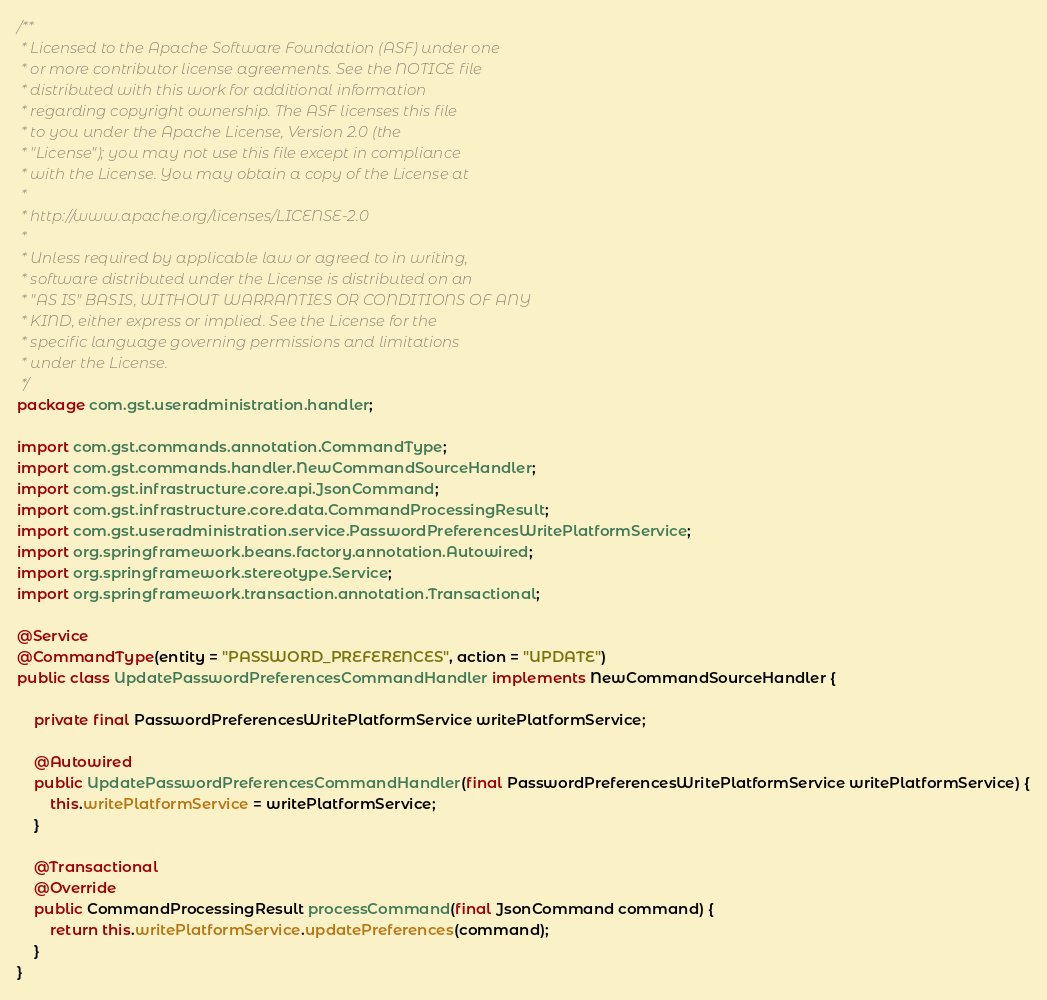<code> <loc_0><loc_0><loc_500><loc_500><_Java_>/**
 * Licensed to the Apache Software Foundation (ASF) under one
 * or more contributor license agreements. See the NOTICE file
 * distributed with this work for additional information
 * regarding copyright ownership. The ASF licenses this file
 * to you under the Apache License, Version 2.0 (the
 * "License"); you may not use this file except in compliance
 * with the License. You may obtain a copy of the License at
 *
 * http://www.apache.org/licenses/LICENSE-2.0
 *
 * Unless required by applicable law or agreed to in writing,
 * software distributed under the License is distributed on an
 * "AS IS" BASIS, WITHOUT WARRANTIES OR CONDITIONS OF ANY
 * KIND, either express or implied. See the License for the
 * specific language governing permissions and limitations
 * under the License.
 */
package com.gst.useradministration.handler;

import com.gst.commands.annotation.CommandType;
import com.gst.commands.handler.NewCommandSourceHandler;
import com.gst.infrastructure.core.api.JsonCommand;
import com.gst.infrastructure.core.data.CommandProcessingResult;
import com.gst.useradministration.service.PasswordPreferencesWritePlatformService;
import org.springframework.beans.factory.annotation.Autowired;
import org.springframework.stereotype.Service;
import org.springframework.transaction.annotation.Transactional;

@Service
@CommandType(entity = "PASSWORD_PREFERENCES", action = "UPDATE")
public class UpdatePasswordPreferencesCommandHandler implements NewCommandSourceHandler {

    private final PasswordPreferencesWritePlatformService writePlatformService;

    @Autowired
    public UpdatePasswordPreferencesCommandHandler(final PasswordPreferencesWritePlatformService writePlatformService) {
        this.writePlatformService = writePlatformService;
    }

    @Transactional
    @Override
    public CommandProcessingResult processCommand(final JsonCommand command) {
        return this.writePlatformService.updatePreferences(command);
    }
}</code> 